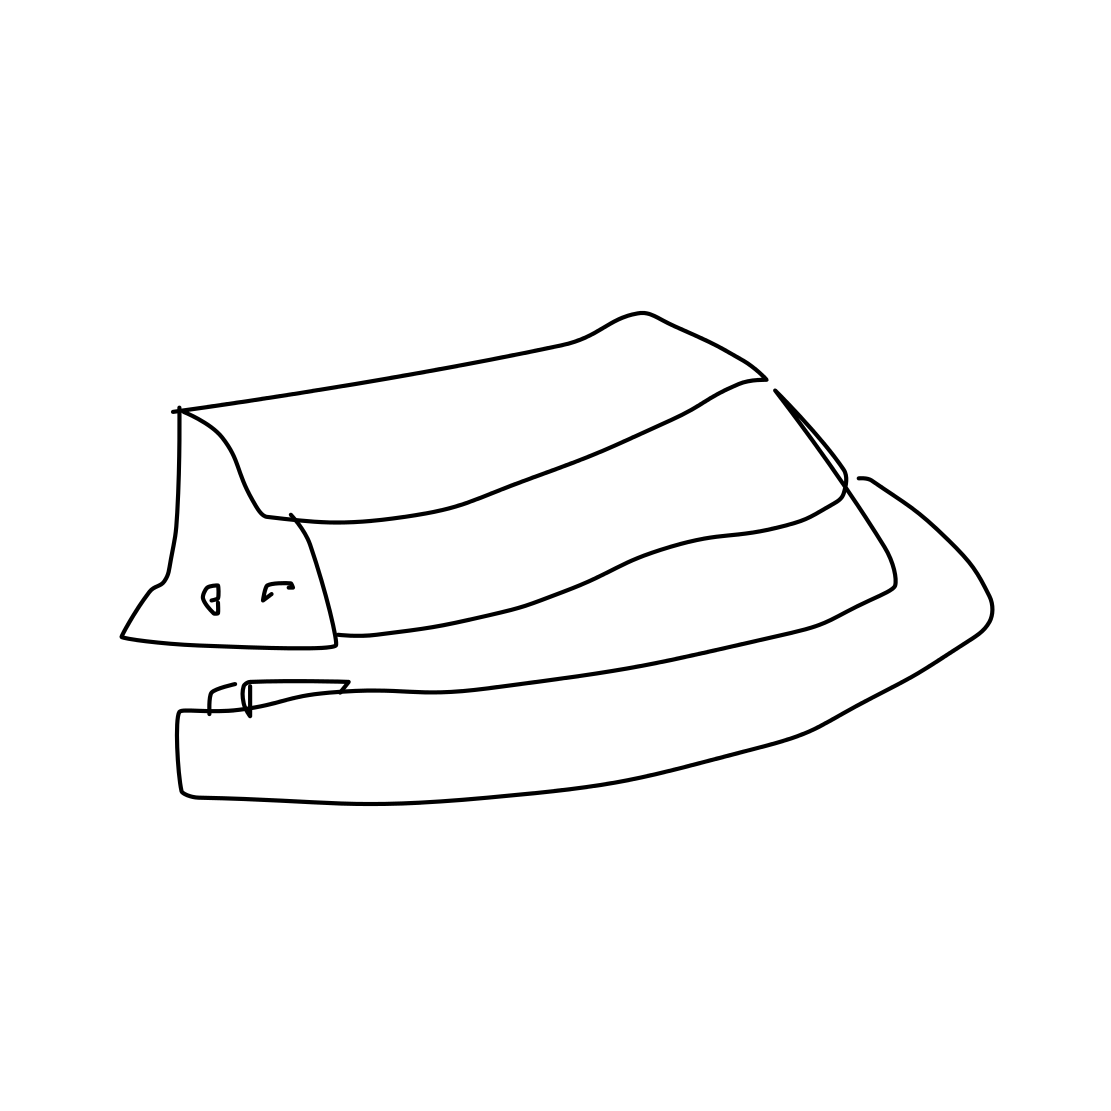This hat appears to be very simple in design. Is there anything that could be added to it to make it more fashionable? To enhance the fashionability of this hat, one could add decorative elements such as a patterned band or feathers, perhaps even a bow or a brooch to give it a unique flair. 